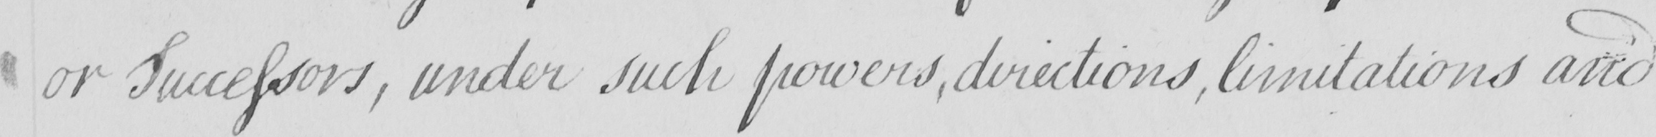Can you tell me what this handwritten text says? or Successors , under such powers , directions , limitations and 